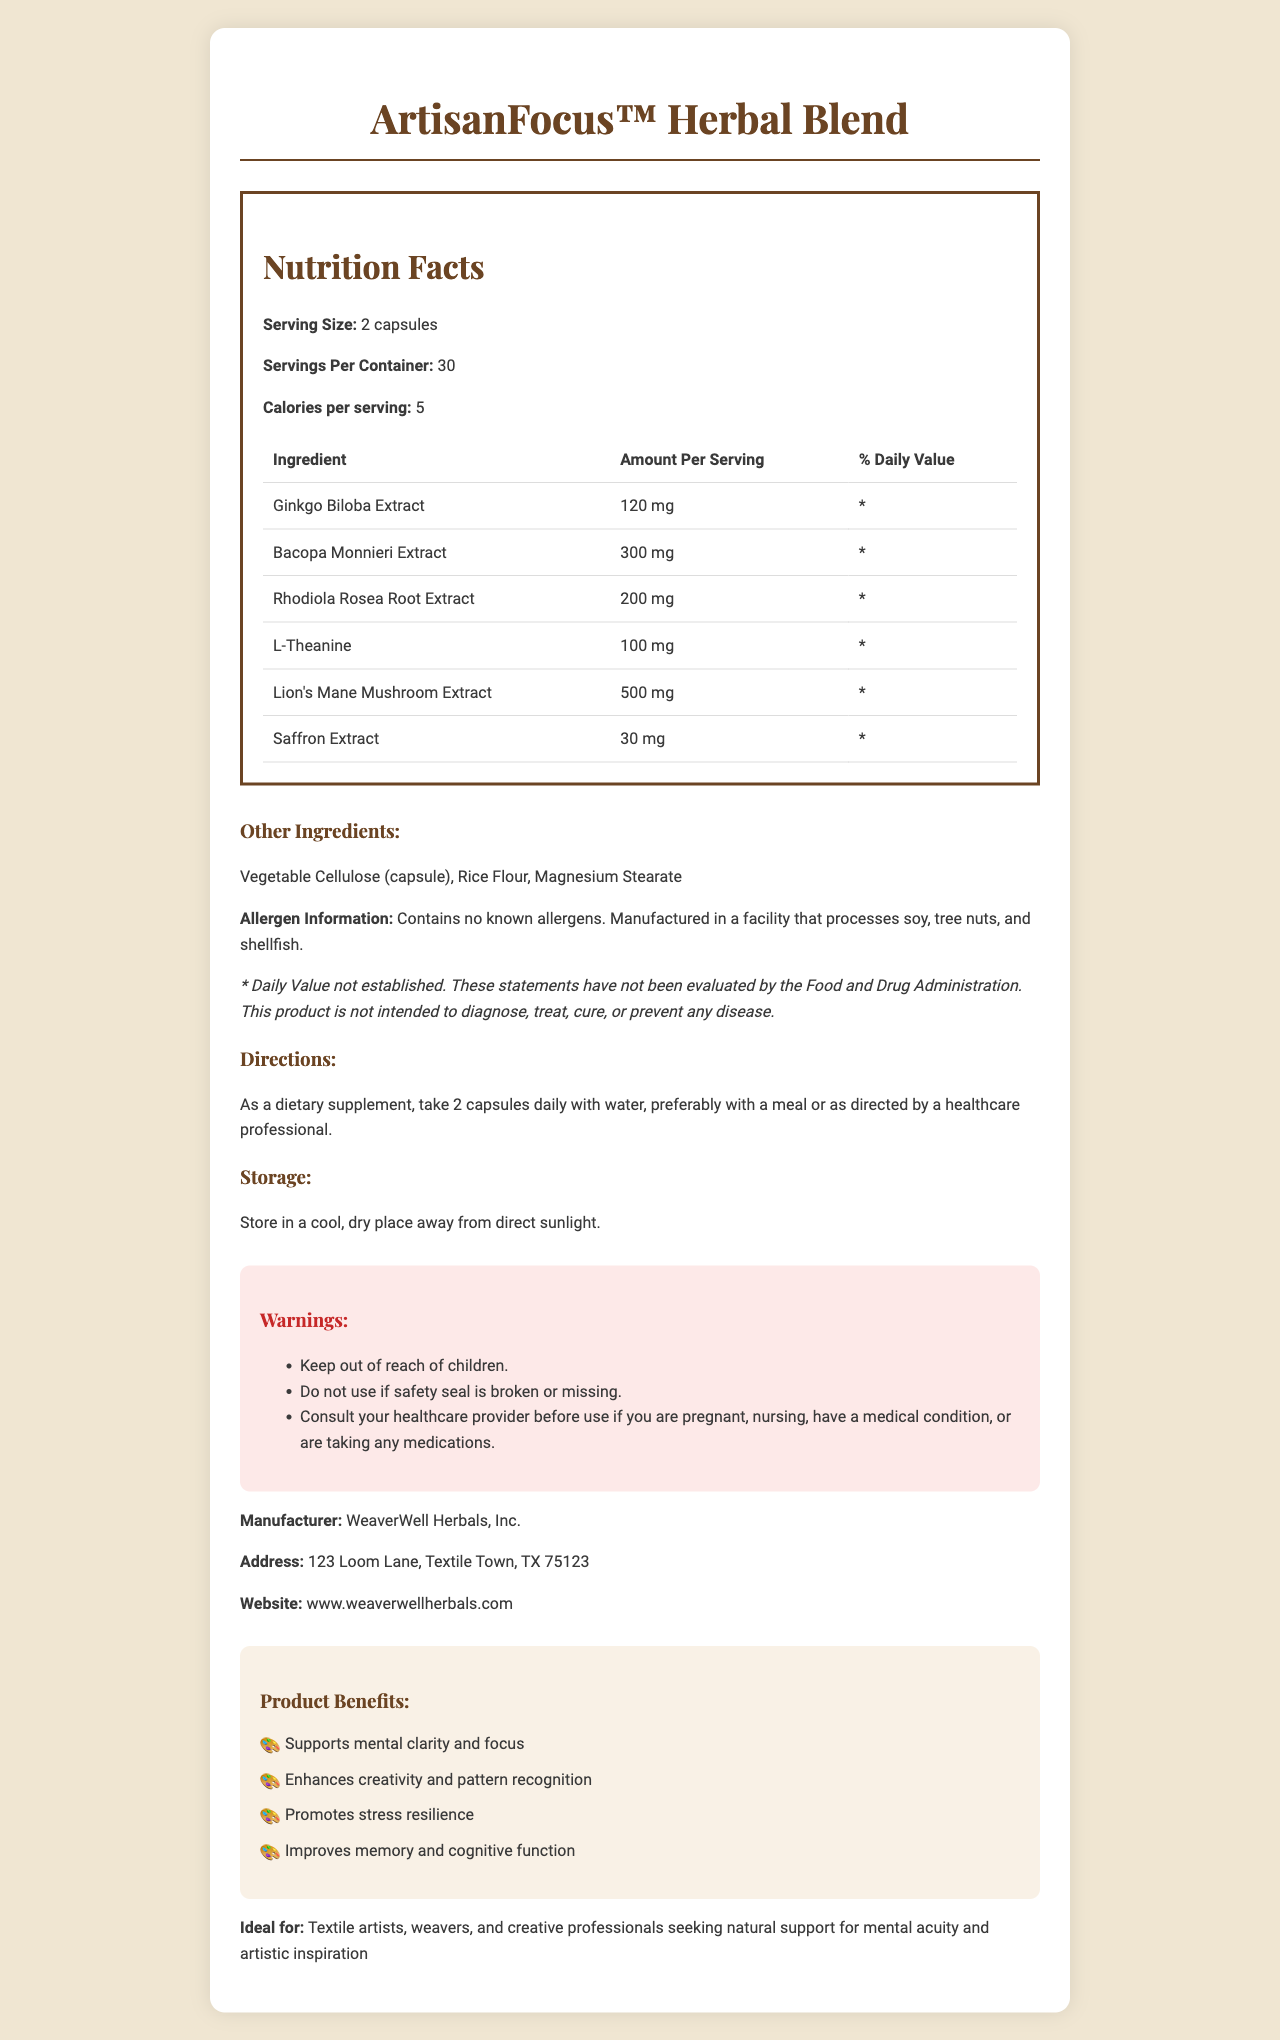what is the serving size of ArtisanFocus™ Herbal Blend? The serving size is clearly mentioned in the document: "Serving Size: 2 capsules."
Answer: 2 capsules how many calories are in each serving? The document states: "Calories per serving: 5".
Answer: 5 calories which ingredient has the highest amount per serving? The ingredient list shows that Lion's Mane Mushroom Extract has the highest amount per serving at 500 mg.
Answer: Lion's Mane Mushroom Extract what are the directions for taking ArtisanFocus™ Herbal Blend? The directions are provided as: "As a dietary supplement, take 2 capsules daily with water, preferably with a meal or as directed by a healthcare professional."
Answer: Take 2 capsules daily with water, preferably with a meal or as directed by a healthcare professional what is the primary purpose of ArtisanFocus™ Herbal Blend? The product is described as designed to "enhance focus and creativity for textile artists."
Answer: To enhance focus and creativity for textile artists how many servings are there in one container? A. 20 B. 30 C. 40 D. 50 The document states that there are "30 servings per container."
Answer: B which ingredient is listed as "Other Ingredients"? I. Vegetable Cellulose II. Rice Flour III. Lion's Mane Mushroom Extract IV. Magnesium Stearate "Vegetable Cellulose (capsule)," "Rice Flour," and "Magnesium Stearate" are listed as other ingredients, not Lion's Mane Mushroom Extract.
Answer: III is there any allergen information provided? The allergen information is given as: "Contains no known allergens. Manufactured in a facility that processes soy, tree nuts, and shellfish."
Answer: Yes describe the key benefits of ArtisanFocus™ Herbal Blend for its intended users The document lists these four key benefits under the "Product Benefits" section.
Answer: Supports mental clarity and focus, enhances creativity and pattern recognition, promotes stress resilience, improves memory and cognitive function is this product safe for children to consume? One of the warnings states: "Keep out of reach of children."
Answer: No who is the manufacturer of ArtisanFocus™ Herbal Blend? The manufacturer information at the end of the document states: "WeaverWell Herbals, Inc."
Answer: WeaverWell Herbals, Inc. where is WeaverWell Herbals, Inc. located? The address provided in the document is: "123 Loom Lane, Textile Town, TX 75123."
Answer: 123 Loom Lane, Textile Town, TX 75123 how should this product be stored? The storage instructions are: "Store in a cool, dry place away from direct sunlight."
Answer: Store in a cool, dry place away from direct sunlight what are the possible effects of using ArtisanFocus™ Herbal Blend without consulting a healthcare provider if pregnant or nursing? The document warns to consult a healthcare provider before use if pregnant, nursing, have a medical condition, or are taking any medications, but does not specify the effects.
Answer: Cannot be determined explain the main idea of the document The document highlights the purpose, usage guidelines, benefits, and safety warnings for the herbal supplement, targeting textile artists and creative professionals.
Answer: The document provides comprehensive details about ArtisanFocus™ Herbal Blend, a herbal supplement designed to enhance focus and creativity for textile artists. It includes information on the serving size, ingredients, nutritional facts, directions for use, storage conditions, warnings, manufacturer details, product benefits, and intended user demographics. 